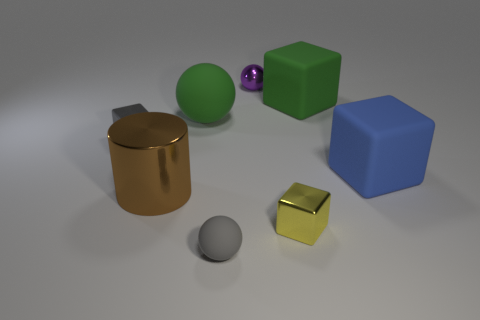What number of objects are gray things or tiny purple shiny objects?
Make the answer very short. 3. Are there any brown metallic spheres?
Offer a terse response. No. Are there fewer purple spheres than green things?
Keep it short and to the point. Yes. Are there any gray balls that have the same size as the green rubber cube?
Ensure brevity in your answer.  No. Does the yellow thing have the same shape as the gray thing behind the gray ball?
Offer a very short reply. Yes. What number of cylinders are either blue matte things or purple things?
Keep it short and to the point. 0. The tiny metal ball is what color?
Your response must be concise. Purple. Is the number of tiny rubber objects greater than the number of cyan shiny objects?
Ensure brevity in your answer.  Yes. How many objects are things to the right of the gray cube or cyan rubber spheres?
Your response must be concise. 7. Are the purple thing and the brown cylinder made of the same material?
Give a very brief answer. Yes. 